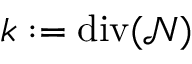<formula> <loc_0><loc_0><loc_500><loc_500>k \colon = d i v ( \mathcal { N } )</formula> 